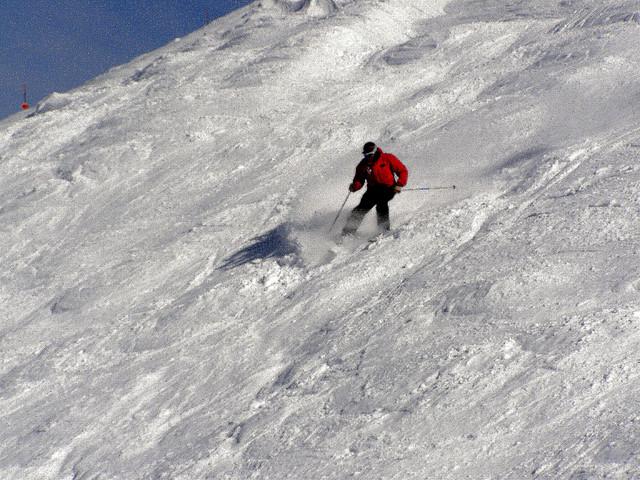What covers the ground?
Short answer required. Snow. Is it cold here?
Quick response, please. Yes. What color is the jacket?
Concise answer only. Red. 